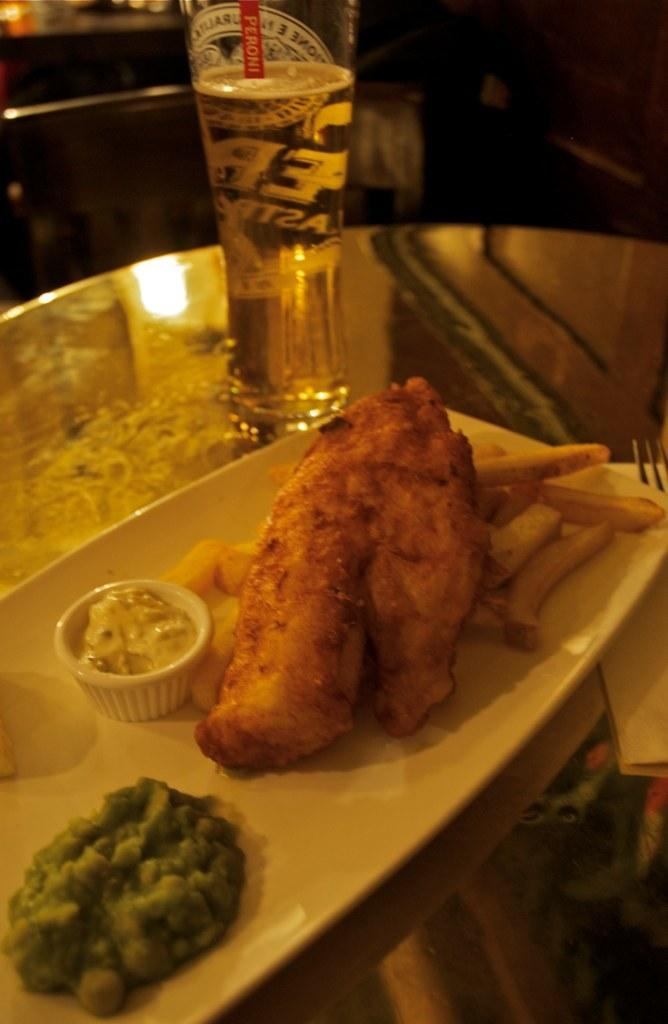<image>
Present a compact description of the photo's key features. A plate of food with a glass that has Peroni written on it. 